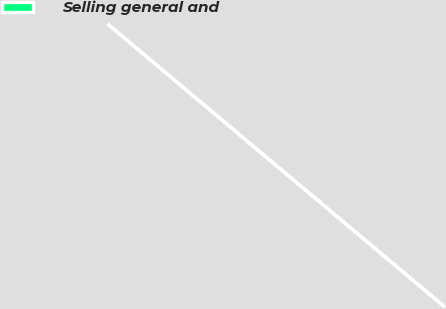<chart> <loc_0><loc_0><loc_500><loc_500><pie_chart><fcel>Selling general and<nl><fcel>100.0%<nl></chart> 